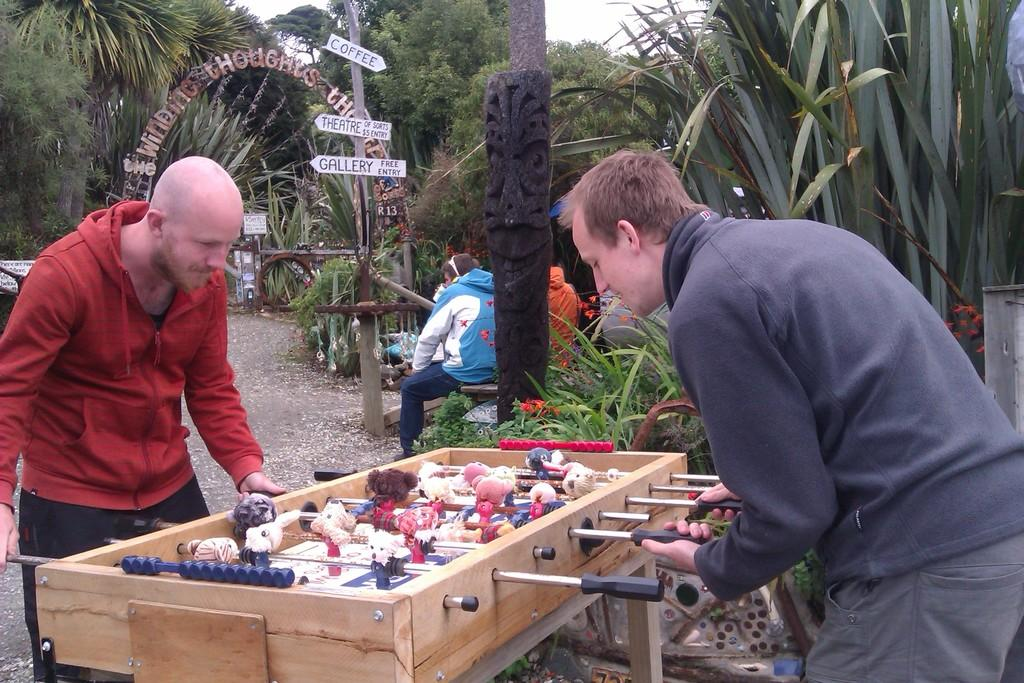Who or what can be seen in the image? There are people in the image. What activity are the people engaged in? They are playing a Foosball game. What is the surface on which the Foosball game is being played? The ground is visible in the image. Can you describe any architectural features in the image? There is an arch in the image. What type of objects are present in the image? There are boards and a pole in the image. Are there any natural elements in the image? Yes, plants and trees are present in the image. What can be seen in the background of the image? The sky is visible in the background of the image. What type of key is used to unlock the society in the image? There is no mention of a key or society in the image; it features people playing a Foosball game, an arch, boards, a pole, plants, trees, and the sky. 